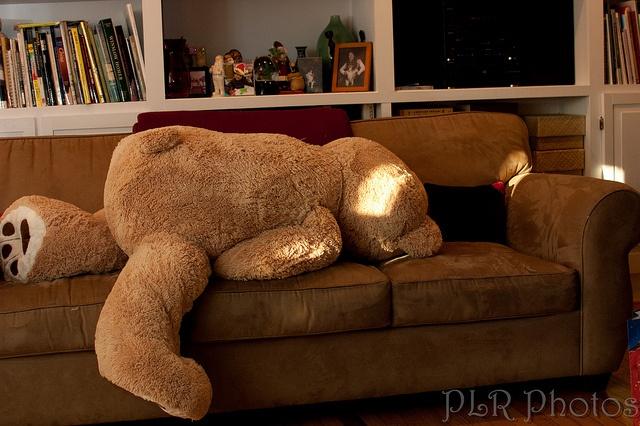Describe the objects in this image and their specific colors. I can see couch in gray, black, maroon, and brown tones, teddy bear in gray, brown, maroon, and tan tones, book in gray, black, and maroon tones, book in gray, black, and maroon tones, and book in gray, black, tan, orange, and brown tones in this image. 